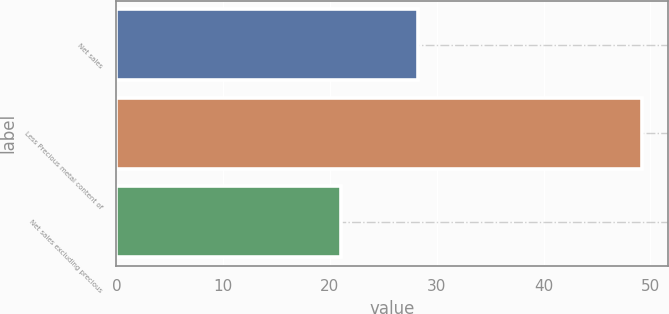<chart> <loc_0><loc_0><loc_500><loc_500><bar_chart><fcel>Net sales<fcel>Less Precious metal content of<fcel>Net sales excluding precious<nl><fcel>28.2<fcel>49.2<fcel>21<nl></chart> 